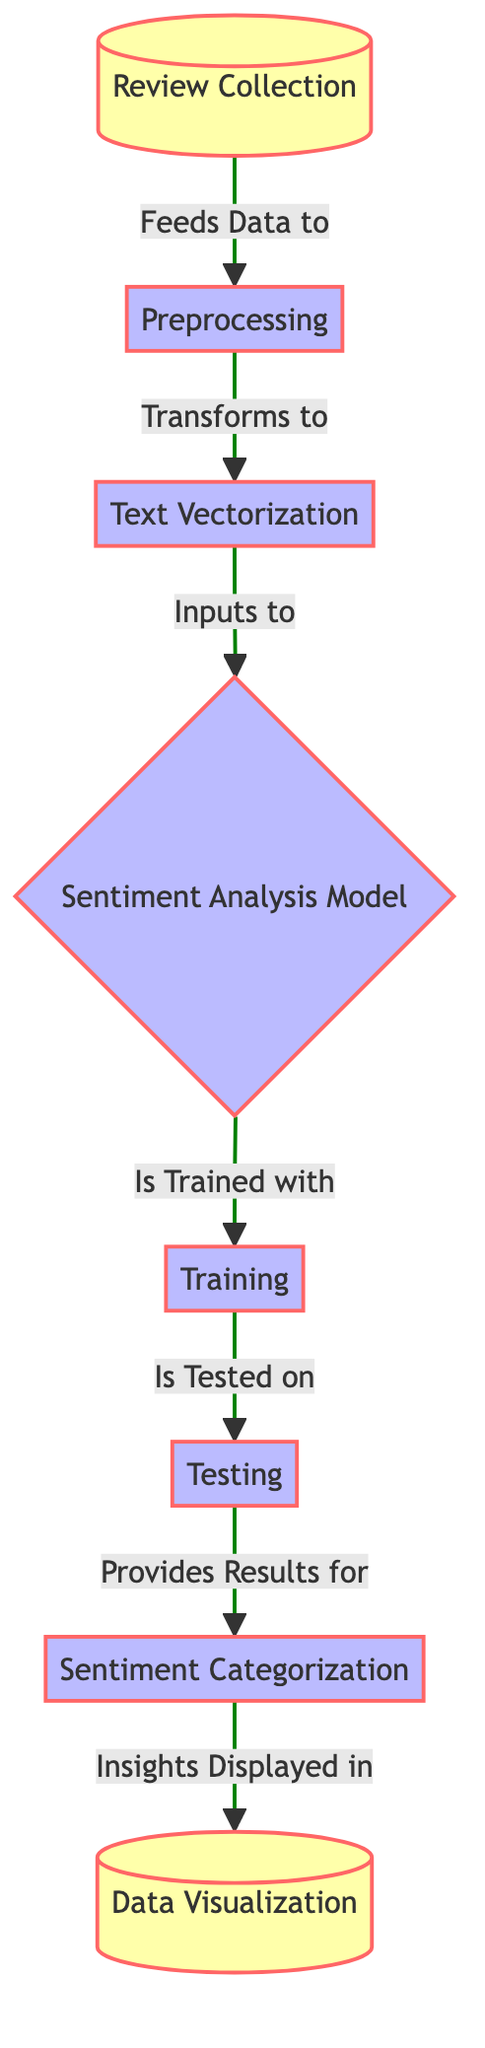What is the first step in the diagram? The first step in the diagram is "Review Collection," which is indicated as the starting node before any processing occurs.
Answer: Review Collection How many processes are depicted in the diagram? There are six process nodes in the diagram: Preprocessing, Text Vectorization, Sentiment Analysis Model, Training, Testing, and Sentiment Categorization.
Answer: Six What connects "Review Collection" and "Preprocessing"? "Review Collection" feeds data to "Preprocessing," indicating a direct flow of data between these two nodes.
Answer: Feeds Data to Which step provides results for sentiment categorization? The "Testing" step provides results for the "Sentiment Categorization," indicating that testing the model yields outcomes that categorize listener feedback.
Answer: Testing What is the final output shown in the diagram? The final output displayed in the diagram is "Data Visualization," which represents the presentation of insights from the analysis process.
Answer: Data Visualization How does "Text Vectorization" relate to the sentiment analysis model? "Text Vectorization" inputs to the "Sentiment Analysis Model," meaning that the transformed text data is used as input for sentiment analysis.
Answer: Inputs to What happens after training the sentiment analysis model? After the "Sentiment Analysis Model" is trained, it goes to the "Testing" phase, where the model's performance is evaluated.
Answer: Testing How many data-related nodes are in the diagram? There are two data-related nodes in the diagram: "Review Collection" and "Data Visualization."
Answer: Two Which process is directly before "Sentiment Categorization"? The process directly before "Sentiment Categorization" is "Testing," which provides the results necessary for categorizing sentiments.
Answer: Testing 